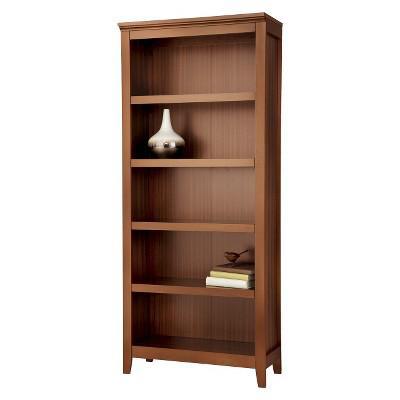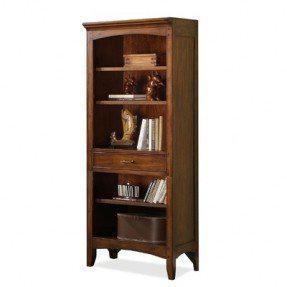The first image is the image on the left, the second image is the image on the right. For the images shown, is this caption "In one image, a bookcase has a drawer in addition to open shelving." true? Answer yes or no. Yes. 